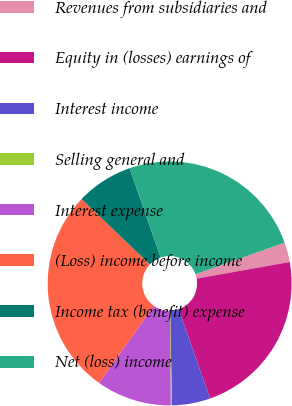Convert chart. <chart><loc_0><loc_0><loc_500><loc_500><pie_chart><fcel>Revenues from subsidiaries and<fcel>Equity in (losses) earnings of<fcel>Interest income<fcel>Selling general and<fcel>Interest expense<fcel>(Loss) income before income<fcel>Income tax (benefit) expense<fcel>Net (loss) income<nl><fcel>2.62%<fcel>22.44%<fcel>5.07%<fcel>0.16%<fcel>9.97%<fcel>27.34%<fcel>7.52%<fcel>24.89%<nl></chart> 